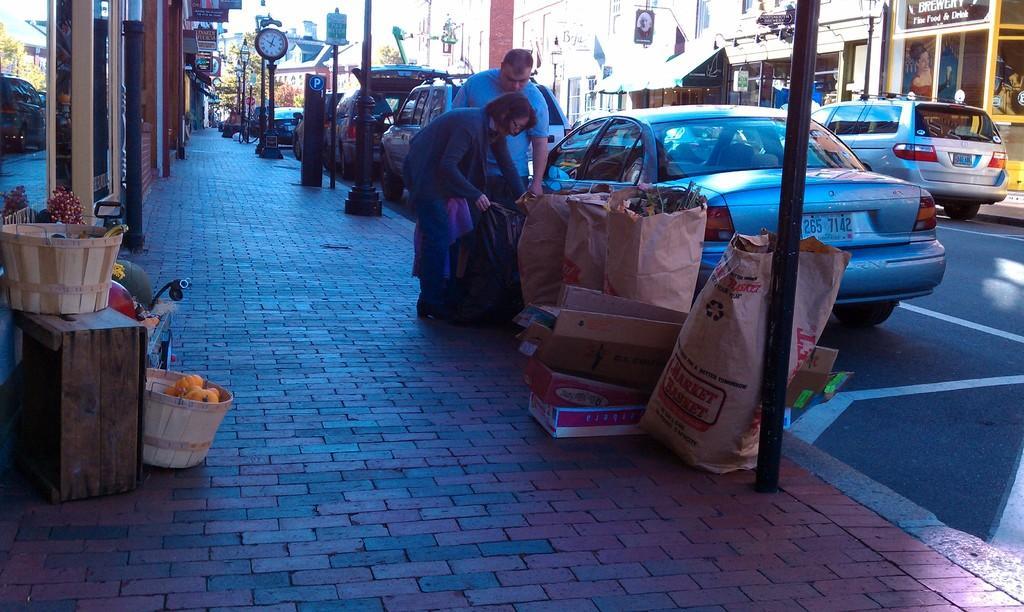Describe this image in one or two sentences. On the left side, there is a basket on a cupboard. Bedside cupboard, there is another basket on the footpath. On the right side, there is a road on which, there are vehicles. Beside this road, there are poles, packets and persons on the footpath. In the background, there are buildings and there are trees. 